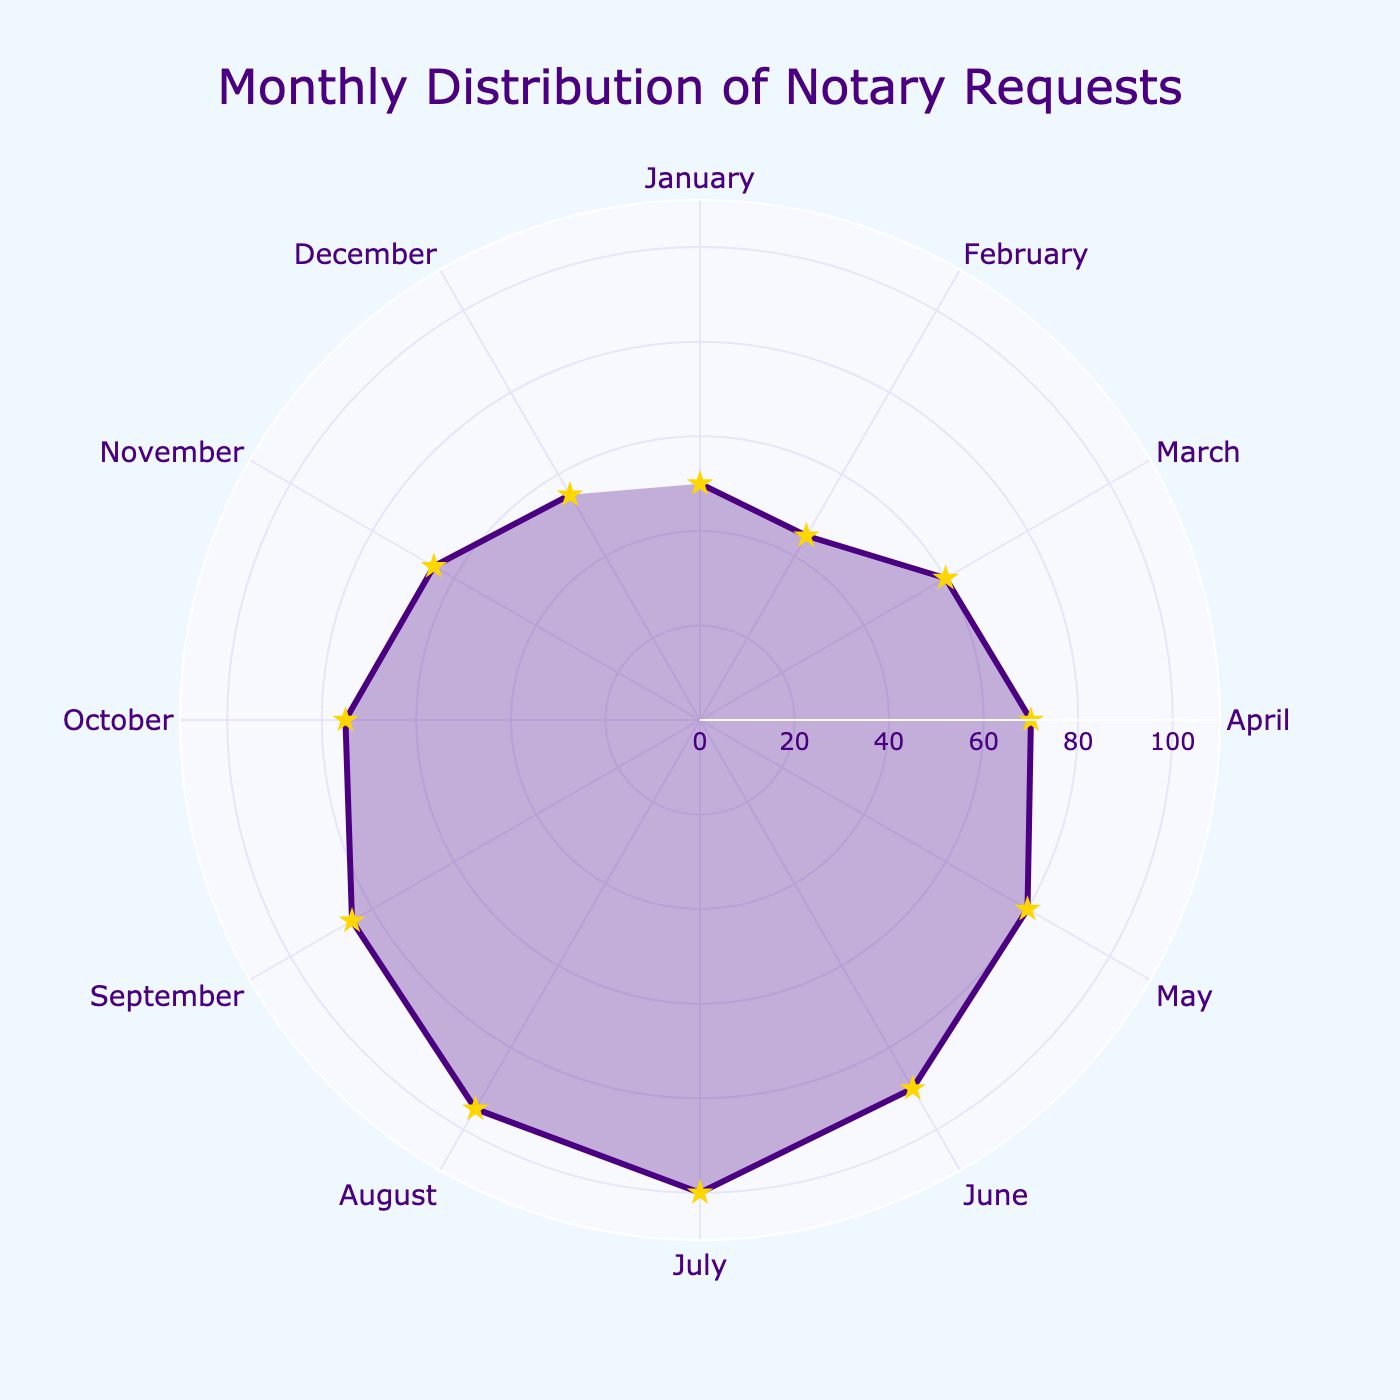What's the title of the chart? The title of the chart is found at the top center of the figure, it reads "Monthly Distribution of Notary Requests".
Answer: Monthly Distribution of Notary Requests What is the range of request values shown on the radial axis? The radial axis represents the number of requests and ranges from 0 to 110. This can be seen from the labels on the radial axis.
Answer: 0 to 110 In which month was the maximum number of notary requests? Identify the month where the radial distance is the greatest. July shows the longest radial distance with 100 requests.
Answer: July Which month had the lowest number of requests? Find the month with the smallest radial distance. January had the smallest number of requests at 50.
Answer: January What's the total number of notary requests in the first quarter (January to March)? Sum the values for January, February, and March: 50 (January) + 45 (February) + 60 (March) = 155.
Answer: 155 How many months had more than 80 requests? Identify the months where the radial distance (requests) is greater than 80. These months are June (90), July (100), August (95), and September (85), making a total of 4 months.
Answer: 4 Which months had fewer requests in November compared to May, and by how many requests? Compare the requests: May (80) vs. November (65). The difference is 80 - 65 = 15.
Answer: 15 What's the average number of notary requests from June to September? Calculate the average for June, July, August, and September: (90 + 100 + 95 + 85) / 4 = 92.5.
Answer: 92.5 Between which two consecutive months do we see the greatest increase in notary requests? Look for the highest increase between consecutive months by subtracting the requests of the previous month from the next. The greatest increase is between June (90) and July (100), with an increase of 100 - 90 = 10.
Answer: June to July 